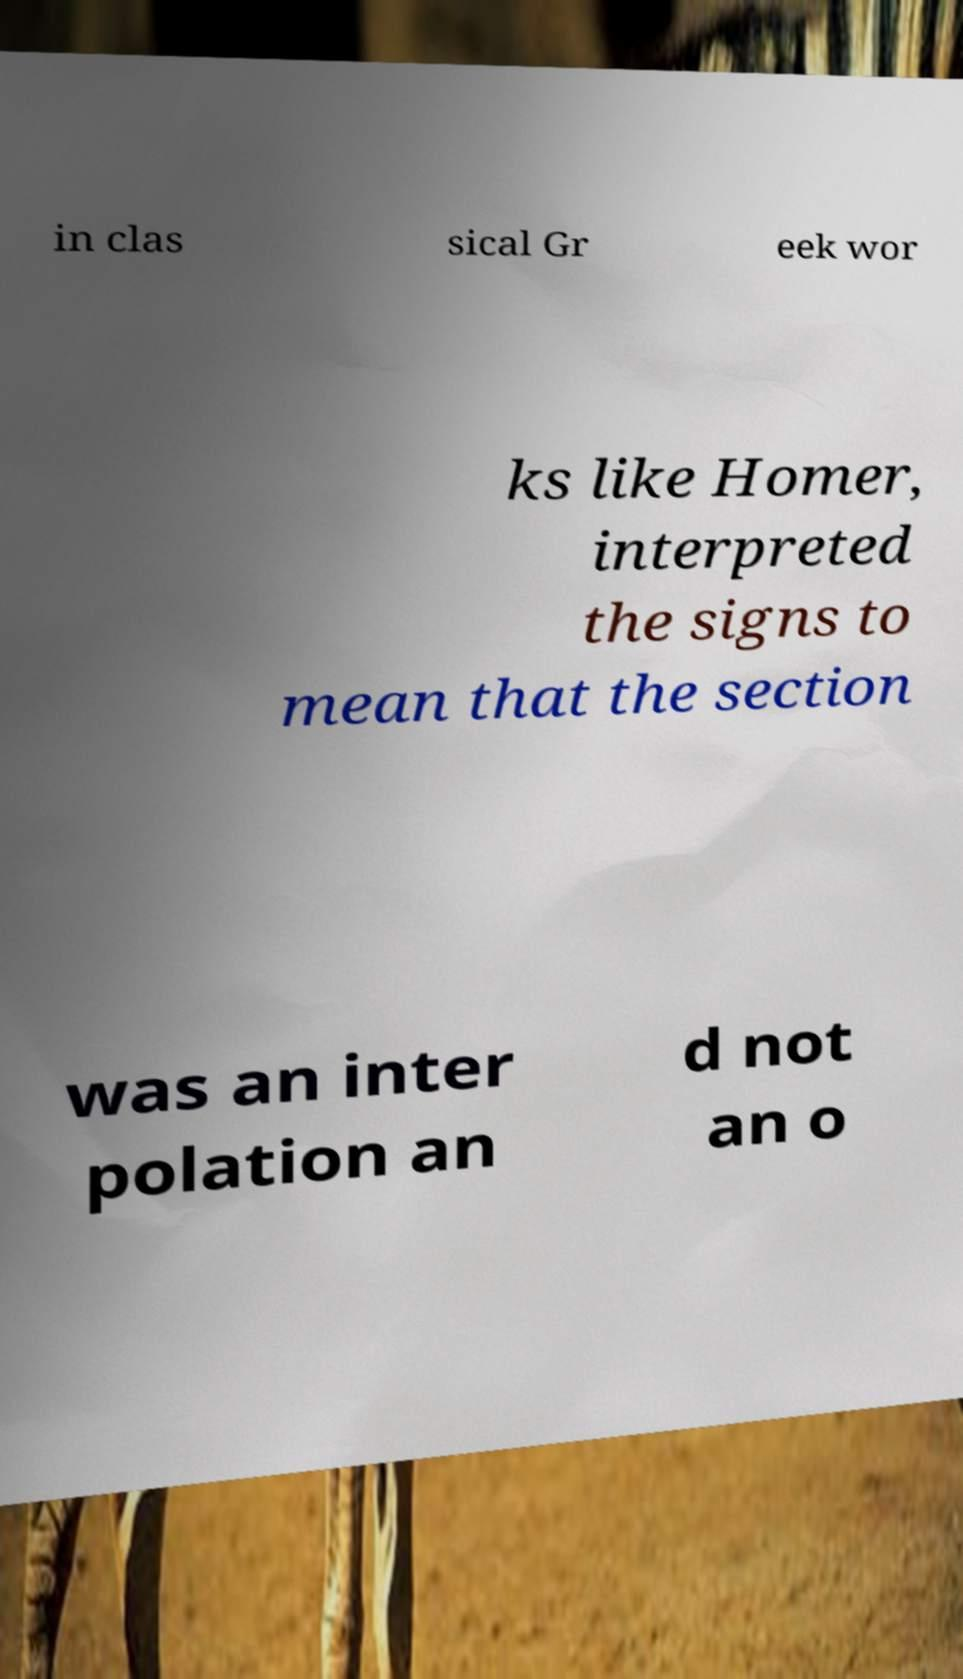For documentation purposes, I need the text within this image transcribed. Could you provide that? in clas sical Gr eek wor ks like Homer, interpreted the signs to mean that the section was an inter polation an d not an o 